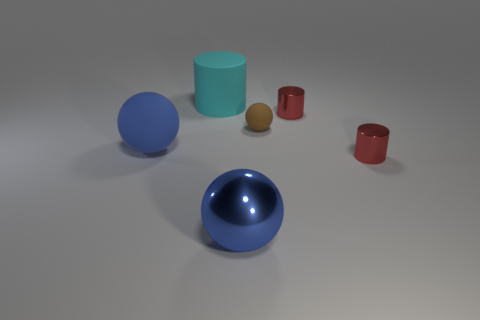Do the cyan cylinder and the metallic ball in front of the brown rubber ball have the same size?
Your answer should be compact. Yes. How many metallic objects are big objects or tiny red cylinders?
Make the answer very short. 3. What number of shiny objects have the same shape as the cyan rubber thing?
Your answer should be compact. 2. There is another ball that is the same color as the large rubber sphere; what is it made of?
Keep it short and to the point. Metal. Is the size of the red metallic cylinder that is in front of the blue rubber sphere the same as the matte sphere that is right of the metal sphere?
Offer a very short reply. Yes. There is a big blue metallic thing that is in front of the tiny brown rubber object; what shape is it?
Give a very brief answer. Sphere. There is another blue thing that is the same shape as the big blue rubber object; what material is it?
Offer a terse response. Metal. Does the blue sphere that is left of the matte cylinder have the same size as the brown rubber thing?
Provide a succinct answer. No. There is a small brown matte thing; how many large cyan things are to the right of it?
Make the answer very short. 0. Are there fewer big rubber spheres that are behind the brown object than red cylinders that are in front of the cyan cylinder?
Your answer should be compact. Yes. 